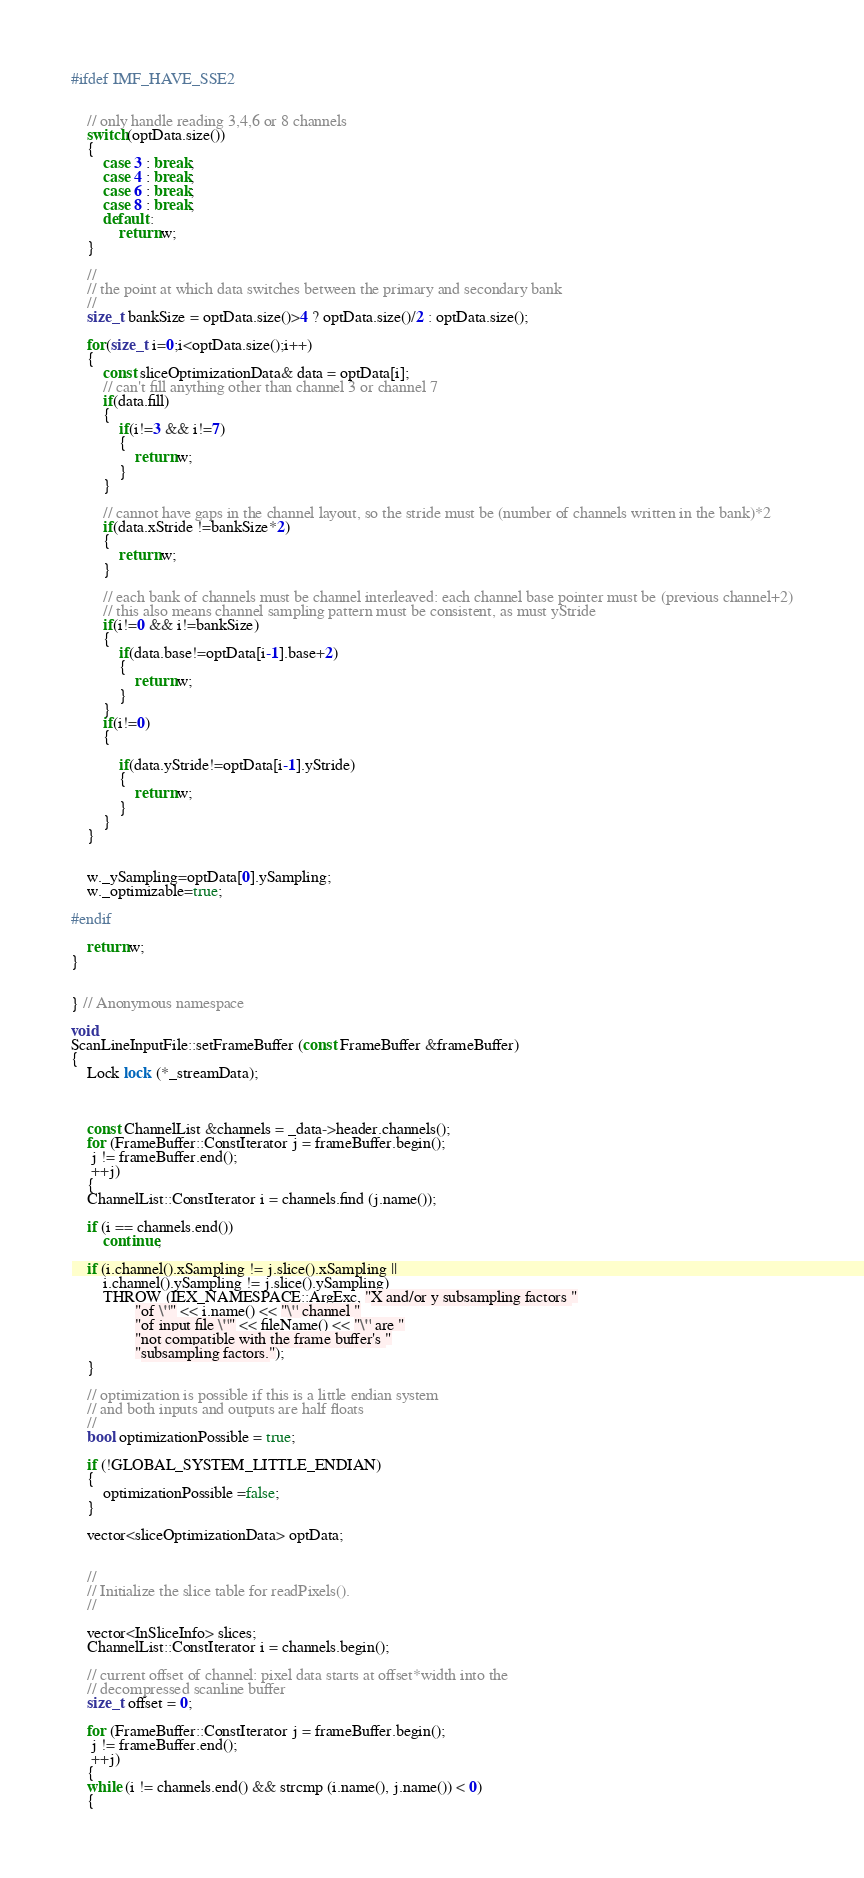Convert code to text. <code><loc_0><loc_0><loc_500><loc_500><_C++_>#ifdef IMF_HAVE_SSE2
    
    
    // only handle reading 3,4,6 or 8 channels
    switch(optData.size())
    {
        case 3 : break;
        case 4 : break;
        case 6 : break;
        case 8 : break;
        default :
            return w;
    }
    
    //
    // the point at which data switches between the primary and secondary bank
    //
    size_t bankSize = optData.size()>4 ? optData.size()/2 : optData.size();
    
    for(size_t i=0;i<optData.size();i++)
    {
        const sliceOptimizationData& data = optData[i];
        // can't fill anything other than channel 3 or channel 7
        if(data.fill)
        {
            if(i!=3 && i!=7)
            {
                return w;
            }
        }
        
        // cannot have gaps in the channel layout, so the stride must be (number of channels written in the bank)*2
        if(data.xStride !=bankSize*2)
        {
            return w;
        }
        
        // each bank of channels must be channel interleaved: each channel base pointer must be (previous channel+2)
        // this also means channel sampling pattern must be consistent, as must yStride
        if(i!=0 && i!=bankSize)
        {
            if(data.base!=optData[i-1].base+2)
            {
                return w;
            }
        }
        if(i!=0)
        {
            
            if(data.yStride!=optData[i-1].yStride)
            {
                return w;
            }
        }
    }
    

    w._ySampling=optData[0].ySampling;
    w._optimizable=true;
    
#endif

    return w;
}


} // Anonymous namespace

void	
ScanLineInputFile::setFrameBuffer (const FrameBuffer &frameBuffer)
{
    Lock lock (*_streamData);

    
    
    const ChannelList &channels = _data->header.channels();
    for (FrameBuffer::ConstIterator j = frameBuffer.begin();
	 j != frameBuffer.end();
	 ++j)
    {
	ChannelList::ConstIterator i = channels.find (j.name());

	if (i == channels.end())
	    continue;

	if (i.channel().xSampling != j.slice().xSampling ||
	    i.channel().ySampling != j.slice().ySampling)
	    THROW (IEX_NAMESPACE::ArgExc, "X and/or y subsampling factors "
				"of \"" << i.name() << "\" channel "
				"of input file \"" << fileName() << "\" are "
				"not compatible with the frame buffer's "
				"subsampling factors.");
    }

    // optimization is possible if this is a little endian system
    // and both inputs and outputs are half floats
    // 
    bool optimizationPossible = true;
    
    if (!GLOBAL_SYSTEM_LITTLE_ENDIAN)
    {
        optimizationPossible =false;
    }
    
    vector<sliceOptimizationData> optData;
    

    //
    // Initialize the slice table for readPixels().
    //

    vector<InSliceInfo> slices;
    ChannelList::ConstIterator i = channels.begin();
    
    // current offset of channel: pixel data starts at offset*width into the
    // decompressed scanline buffer
    size_t offset = 0;
    
    for (FrameBuffer::ConstIterator j = frameBuffer.begin();
	 j != frameBuffer.end();
	 ++j)
    {
	while (i != channels.end() && strcmp (i.name(), j.name()) < 0)
	{</code> 